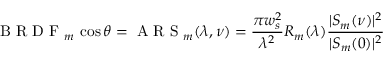Convert formula to latex. <formula><loc_0><loc_0><loc_500><loc_500>B R D F _ { m } \cos \theta = A R S _ { m } ( \lambda , \nu ) = \frac { \pi w _ { s } ^ { 2 } } { \lambda ^ { 2 } } R _ { m } ( \lambda ) \frac { | S _ { m } ( \nu ) | ^ { 2 } } { | S _ { m } ( 0 ) | ^ { 2 } }</formula> 